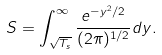<formula> <loc_0><loc_0><loc_500><loc_500>S = \int ^ { \infty } _ { \sqrt { T _ { s } } } \frac { e ^ { - y ^ { 2 } / 2 } } { ( 2 \pi ) ^ { 1 / 2 } } d y .</formula> 